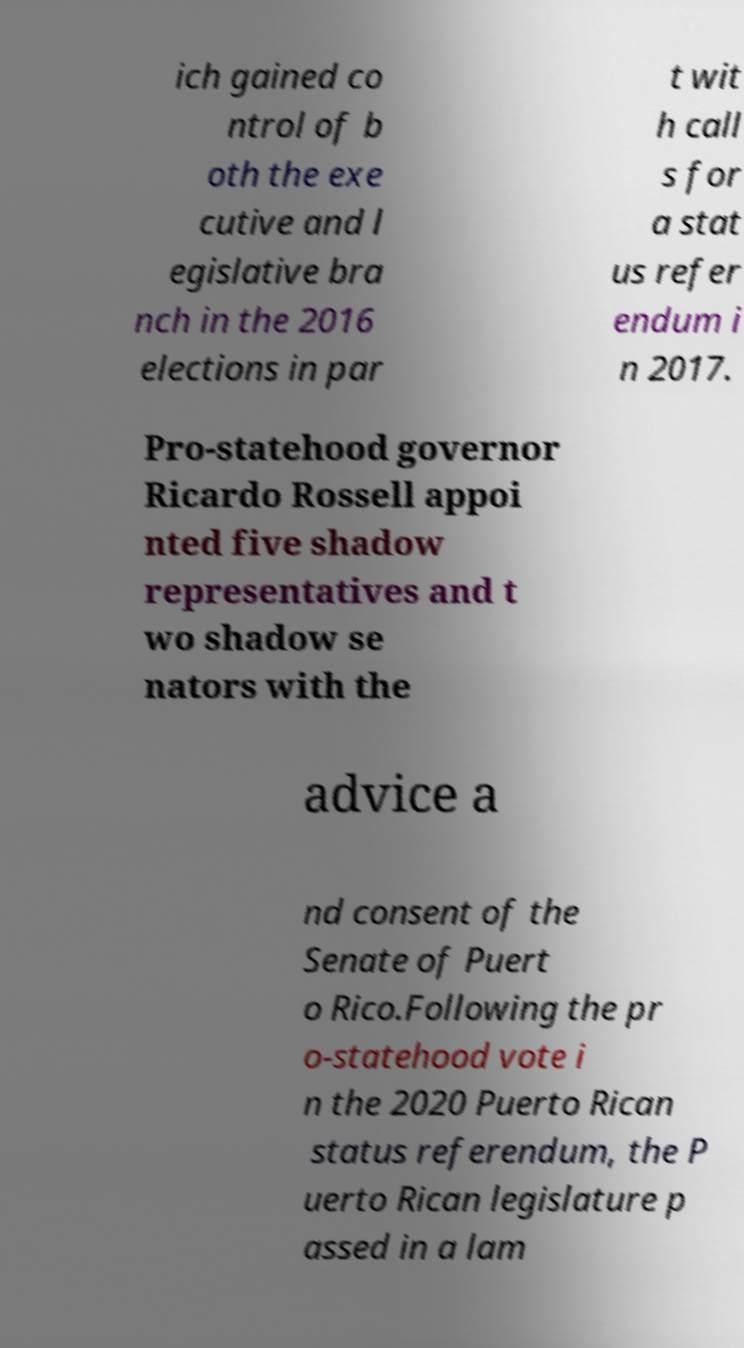Please identify and transcribe the text found in this image. ich gained co ntrol of b oth the exe cutive and l egislative bra nch in the 2016 elections in par t wit h call s for a stat us refer endum i n 2017. Pro-statehood governor Ricardo Rossell appoi nted five shadow representatives and t wo shadow se nators with the advice a nd consent of the Senate of Puert o Rico.Following the pr o-statehood vote i n the 2020 Puerto Rican status referendum, the P uerto Rican legislature p assed in a lam 